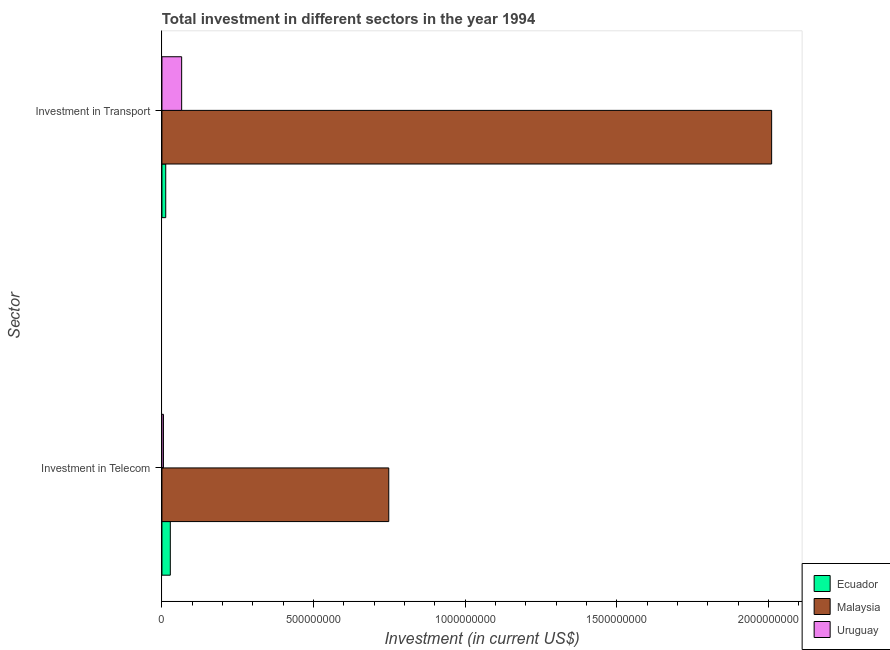How many different coloured bars are there?
Offer a very short reply. 3. How many groups of bars are there?
Ensure brevity in your answer.  2. How many bars are there on the 1st tick from the top?
Give a very brief answer. 3. How many bars are there on the 2nd tick from the bottom?
Make the answer very short. 3. What is the label of the 2nd group of bars from the top?
Your answer should be very brief. Investment in Telecom. What is the investment in telecom in Ecuador?
Ensure brevity in your answer.  2.76e+07. Across all countries, what is the maximum investment in telecom?
Make the answer very short. 7.48e+08. Across all countries, what is the minimum investment in transport?
Keep it short and to the point. 1.25e+07. In which country was the investment in transport maximum?
Make the answer very short. Malaysia. In which country was the investment in telecom minimum?
Your answer should be very brief. Uruguay. What is the total investment in transport in the graph?
Your response must be concise. 2.09e+09. What is the difference between the investment in telecom in Malaysia and that in Uruguay?
Make the answer very short. 7.43e+08. What is the difference between the investment in transport in Uruguay and the investment in telecom in Malaysia?
Give a very brief answer. -6.83e+08. What is the average investment in transport per country?
Offer a terse response. 6.96e+08. What is the difference between the investment in transport and investment in telecom in Uruguay?
Ensure brevity in your answer.  6.00e+07. What is the ratio of the investment in telecom in Malaysia to that in Ecuador?
Provide a succinct answer. 27.1. What does the 2nd bar from the top in Investment in Telecom represents?
Your response must be concise. Malaysia. What does the 2nd bar from the bottom in Investment in Transport represents?
Make the answer very short. Malaysia. How many bars are there?
Your response must be concise. 6. How many countries are there in the graph?
Offer a terse response. 3. What is the difference between two consecutive major ticks on the X-axis?
Provide a succinct answer. 5.00e+08. Are the values on the major ticks of X-axis written in scientific E-notation?
Your answer should be very brief. No. Does the graph contain any zero values?
Provide a succinct answer. No. How many legend labels are there?
Your answer should be very brief. 3. What is the title of the graph?
Give a very brief answer. Total investment in different sectors in the year 1994. Does "Bahamas" appear as one of the legend labels in the graph?
Your answer should be very brief. No. What is the label or title of the X-axis?
Your answer should be very brief. Investment (in current US$). What is the label or title of the Y-axis?
Provide a short and direct response. Sector. What is the Investment (in current US$) of Ecuador in Investment in Telecom?
Keep it short and to the point. 2.76e+07. What is the Investment (in current US$) in Malaysia in Investment in Telecom?
Your answer should be very brief. 7.48e+08. What is the Investment (in current US$) in Uruguay in Investment in Telecom?
Give a very brief answer. 5.00e+06. What is the Investment (in current US$) of Ecuador in Investment in Transport?
Give a very brief answer. 1.25e+07. What is the Investment (in current US$) of Malaysia in Investment in Transport?
Your response must be concise. 2.01e+09. What is the Investment (in current US$) of Uruguay in Investment in Transport?
Your answer should be compact. 6.50e+07. Across all Sector, what is the maximum Investment (in current US$) in Ecuador?
Make the answer very short. 2.76e+07. Across all Sector, what is the maximum Investment (in current US$) in Malaysia?
Give a very brief answer. 2.01e+09. Across all Sector, what is the maximum Investment (in current US$) in Uruguay?
Give a very brief answer. 6.50e+07. Across all Sector, what is the minimum Investment (in current US$) in Ecuador?
Give a very brief answer. 1.25e+07. Across all Sector, what is the minimum Investment (in current US$) in Malaysia?
Ensure brevity in your answer.  7.48e+08. What is the total Investment (in current US$) of Ecuador in the graph?
Your answer should be very brief. 4.01e+07. What is the total Investment (in current US$) in Malaysia in the graph?
Provide a succinct answer. 2.76e+09. What is the total Investment (in current US$) of Uruguay in the graph?
Your answer should be very brief. 7.00e+07. What is the difference between the Investment (in current US$) of Ecuador in Investment in Telecom and that in Investment in Transport?
Give a very brief answer. 1.51e+07. What is the difference between the Investment (in current US$) of Malaysia in Investment in Telecom and that in Investment in Transport?
Offer a very short reply. -1.26e+09. What is the difference between the Investment (in current US$) of Uruguay in Investment in Telecom and that in Investment in Transport?
Keep it short and to the point. -6.00e+07. What is the difference between the Investment (in current US$) of Ecuador in Investment in Telecom and the Investment (in current US$) of Malaysia in Investment in Transport?
Offer a terse response. -1.98e+09. What is the difference between the Investment (in current US$) in Ecuador in Investment in Telecom and the Investment (in current US$) in Uruguay in Investment in Transport?
Keep it short and to the point. -3.74e+07. What is the difference between the Investment (in current US$) of Malaysia in Investment in Telecom and the Investment (in current US$) of Uruguay in Investment in Transport?
Offer a very short reply. 6.83e+08. What is the average Investment (in current US$) in Ecuador per Sector?
Offer a very short reply. 2.00e+07. What is the average Investment (in current US$) in Malaysia per Sector?
Give a very brief answer. 1.38e+09. What is the average Investment (in current US$) of Uruguay per Sector?
Your answer should be very brief. 3.50e+07. What is the difference between the Investment (in current US$) of Ecuador and Investment (in current US$) of Malaysia in Investment in Telecom?
Your response must be concise. -7.20e+08. What is the difference between the Investment (in current US$) in Ecuador and Investment (in current US$) in Uruguay in Investment in Telecom?
Keep it short and to the point. 2.26e+07. What is the difference between the Investment (in current US$) of Malaysia and Investment (in current US$) of Uruguay in Investment in Telecom?
Offer a very short reply. 7.43e+08. What is the difference between the Investment (in current US$) of Ecuador and Investment (in current US$) of Malaysia in Investment in Transport?
Give a very brief answer. -2.00e+09. What is the difference between the Investment (in current US$) of Ecuador and Investment (in current US$) of Uruguay in Investment in Transport?
Provide a succinct answer. -5.25e+07. What is the difference between the Investment (in current US$) of Malaysia and Investment (in current US$) of Uruguay in Investment in Transport?
Offer a very short reply. 1.95e+09. What is the ratio of the Investment (in current US$) of Ecuador in Investment in Telecom to that in Investment in Transport?
Ensure brevity in your answer.  2.21. What is the ratio of the Investment (in current US$) of Malaysia in Investment in Telecom to that in Investment in Transport?
Provide a short and direct response. 0.37. What is the ratio of the Investment (in current US$) in Uruguay in Investment in Telecom to that in Investment in Transport?
Your answer should be very brief. 0.08. What is the difference between the highest and the second highest Investment (in current US$) in Ecuador?
Offer a terse response. 1.51e+07. What is the difference between the highest and the second highest Investment (in current US$) in Malaysia?
Provide a succinct answer. 1.26e+09. What is the difference between the highest and the second highest Investment (in current US$) of Uruguay?
Offer a very short reply. 6.00e+07. What is the difference between the highest and the lowest Investment (in current US$) of Ecuador?
Your answer should be very brief. 1.51e+07. What is the difference between the highest and the lowest Investment (in current US$) in Malaysia?
Provide a short and direct response. 1.26e+09. What is the difference between the highest and the lowest Investment (in current US$) of Uruguay?
Make the answer very short. 6.00e+07. 